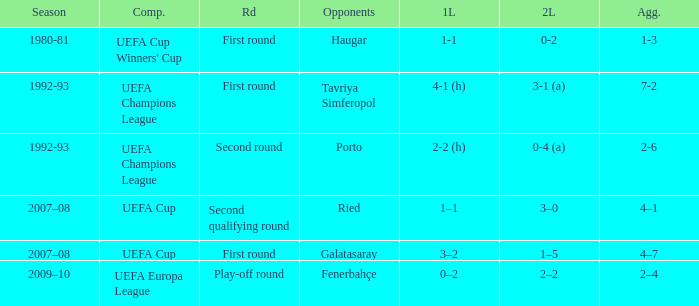What is the total number of round where opponents is haugar 1.0. 